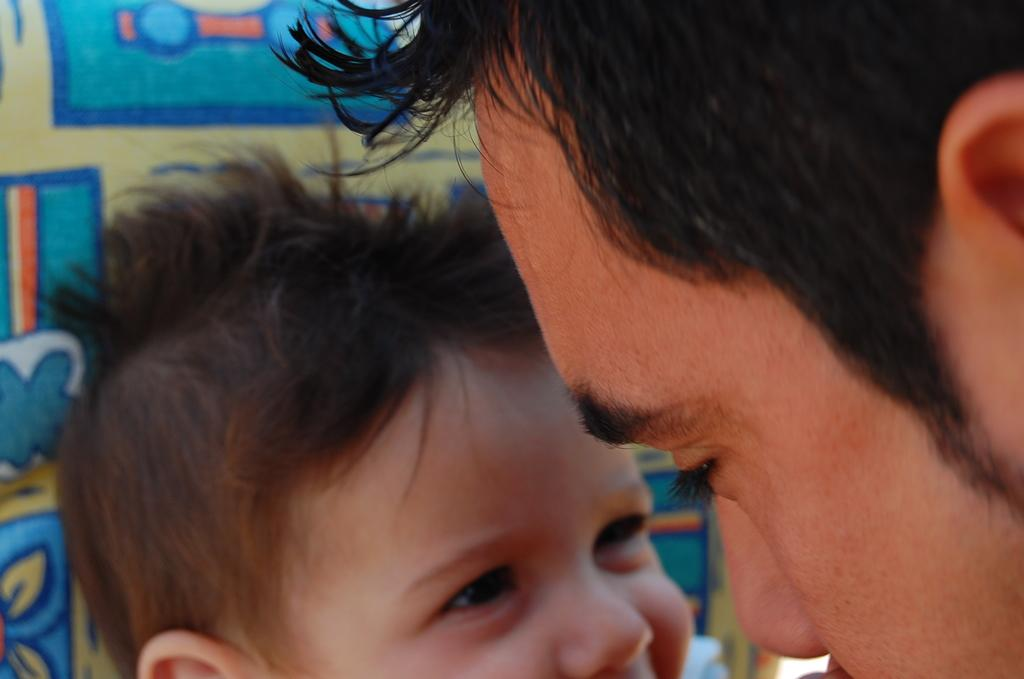What can be seen on the right side of the image? There is a person's head on the right side of the image. What is located on the left side of the image? There is a kid's head on the left side of the image. Can you describe the design in the background of the image? There is a design on a platform in the background of the image. How many vans can be seen in the image? There are no vans present in the image. What type of thing is the crowd holding in the image? There is no crowd present in the image. 